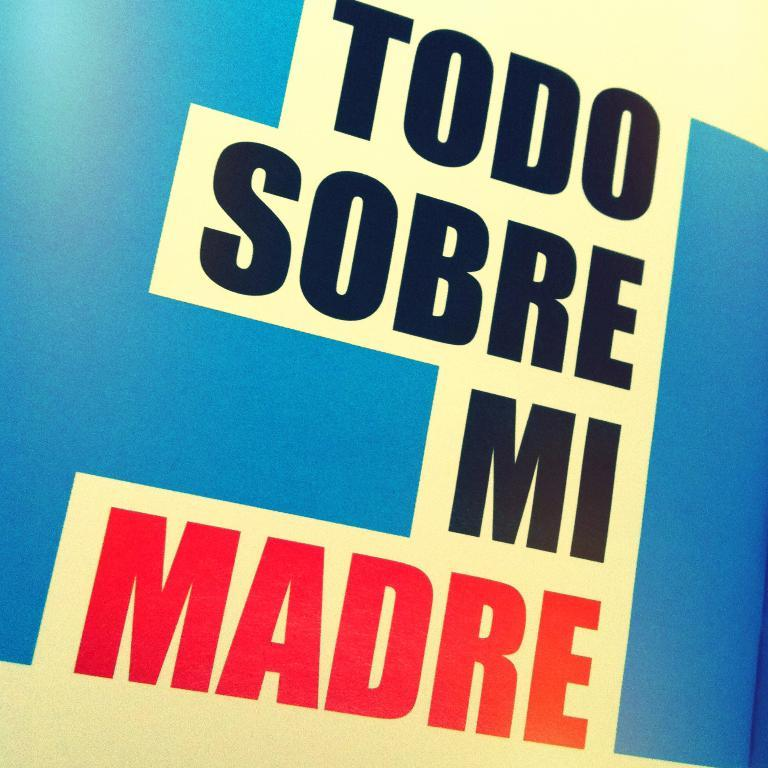<image>
Describe the image concisely. Poster that says Todo Sobre Mi Madre in spanish 